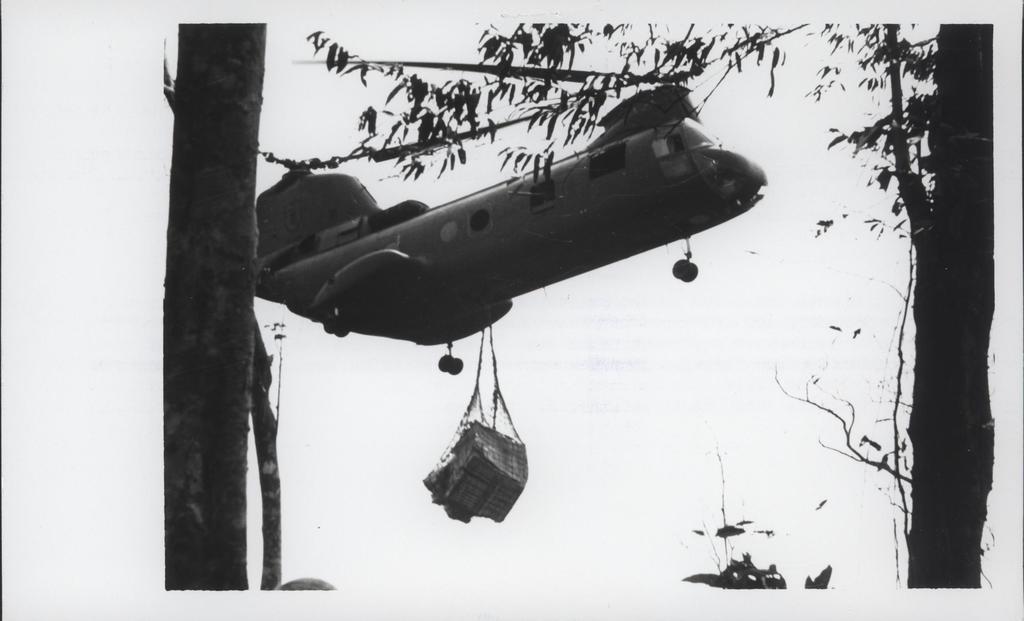Could you give a brief overview of what you see in this image? This is a black and white image. In this there is a aircraft with a luggage hanging on that. Also there are trees. 